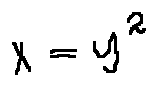<formula> <loc_0><loc_0><loc_500><loc_500>x = y ^ { 2 }</formula> 